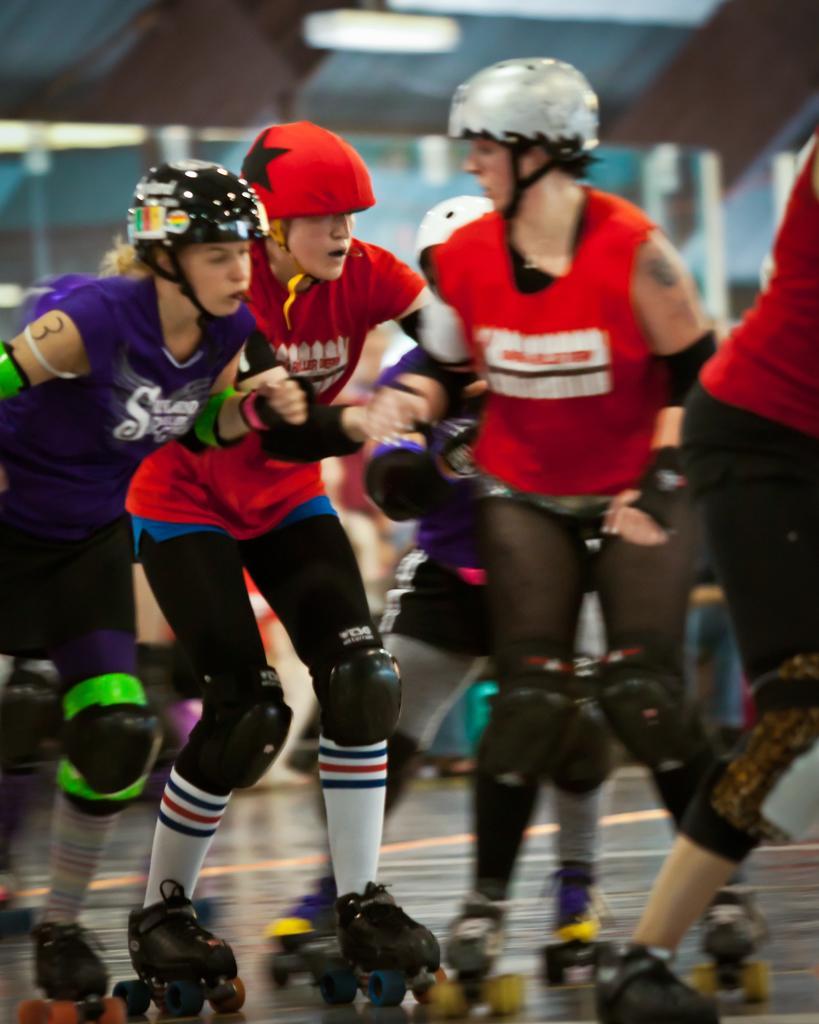Could you give a brief overview of what you see in this image? In this image we can see a group of people wearing helmets and skates and behind them, we can also see few lights hanging from the roof. 